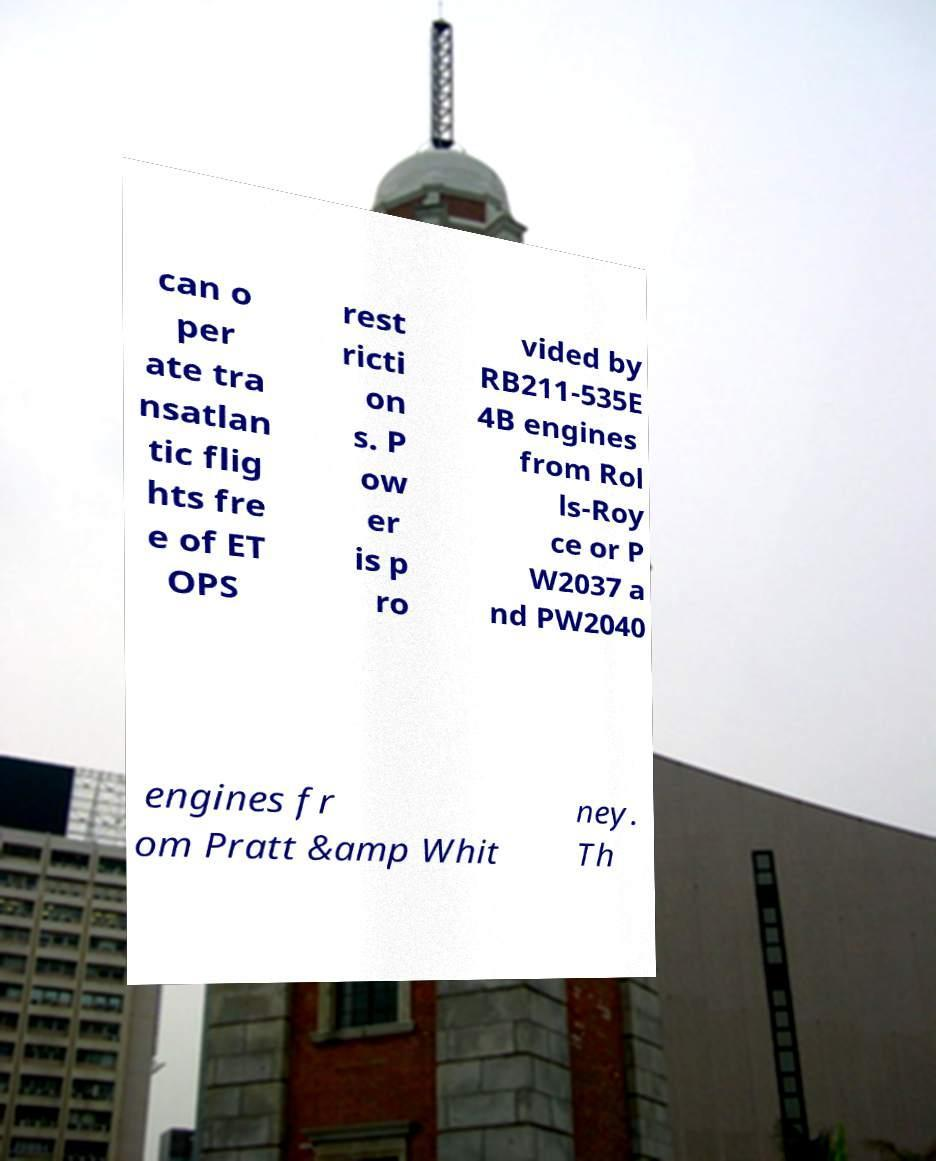Please identify and transcribe the text found in this image. can o per ate tra nsatlan tic flig hts fre e of ET OPS rest ricti on s. P ow er is p ro vided by RB211-535E 4B engines from Rol ls-Roy ce or P W2037 a nd PW2040 engines fr om Pratt &amp Whit ney. Th 